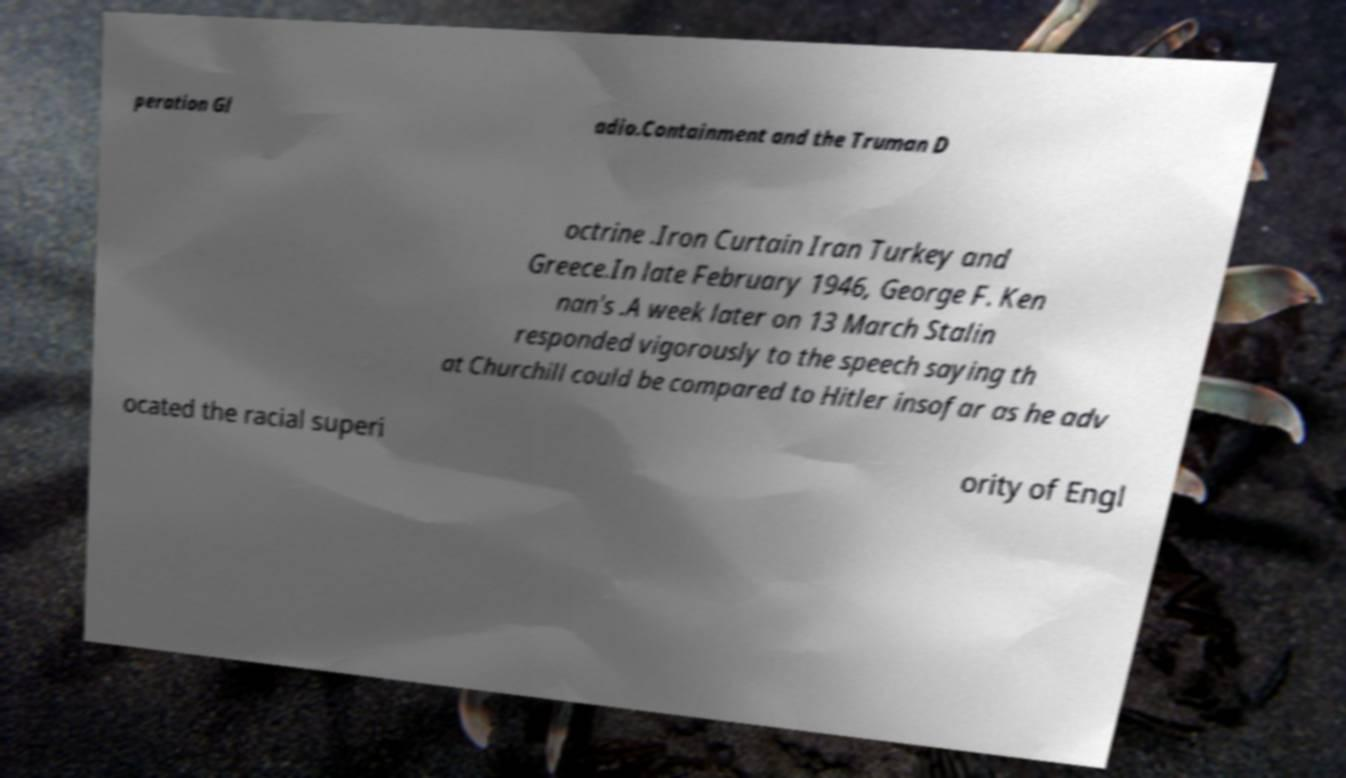Could you assist in decoding the text presented in this image and type it out clearly? peration Gl adio.Containment and the Truman D octrine .Iron Curtain Iran Turkey and Greece.In late February 1946, George F. Ken nan's .A week later on 13 March Stalin responded vigorously to the speech saying th at Churchill could be compared to Hitler insofar as he adv ocated the racial superi ority of Engl 